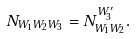Convert formula to latex. <formula><loc_0><loc_0><loc_500><loc_500>N _ { W _ { 1 } W _ { 2 } W _ { 3 } } = N ^ { W ^ { \prime } _ { 3 } } _ { W _ { 1 } W _ { 2 } } .</formula> 